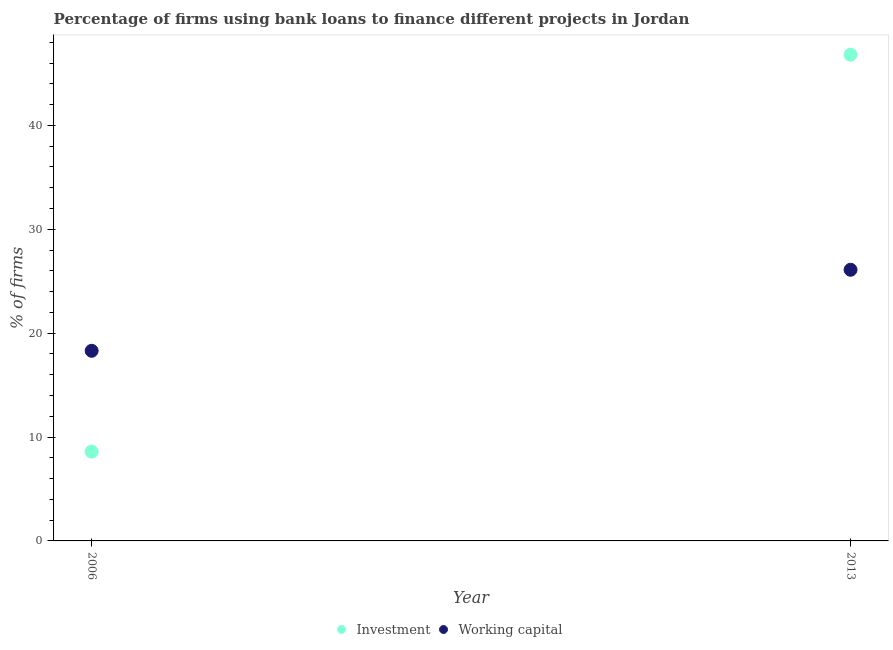Is the number of dotlines equal to the number of legend labels?
Give a very brief answer. Yes. Across all years, what is the maximum percentage of firms using banks to finance working capital?
Your answer should be very brief. 26.1. What is the total percentage of firms using banks to finance investment in the graph?
Make the answer very short. 55.4. What is the difference between the percentage of firms using banks to finance working capital in 2006 and that in 2013?
Your answer should be very brief. -7.8. What is the difference between the percentage of firms using banks to finance working capital in 2006 and the percentage of firms using banks to finance investment in 2013?
Provide a short and direct response. -28.5. What is the average percentage of firms using banks to finance working capital per year?
Provide a succinct answer. 22.2. In the year 2013, what is the difference between the percentage of firms using banks to finance working capital and percentage of firms using banks to finance investment?
Keep it short and to the point. -20.7. What is the ratio of the percentage of firms using banks to finance working capital in 2006 to that in 2013?
Give a very brief answer. 0.7. Is the percentage of firms using banks to finance investment in 2006 less than that in 2013?
Offer a very short reply. Yes. In how many years, is the percentage of firms using banks to finance investment greater than the average percentage of firms using banks to finance investment taken over all years?
Keep it short and to the point. 1. Does the percentage of firms using banks to finance working capital monotonically increase over the years?
Provide a short and direct response. Yes. How many years are there in the graph?
Give a very brief answer. 2. Does the graph contain any zero values?
Make the answer very short. No. Does the graph contain grids?
Keep it short and to the point. No. Where does the legend appear in the graph?
Ensure brevity in your answer.  Bottom center. How many legend labels are there?
Make the answer very short. 2. What is the title of the graph?
Your answer should be compact. Percentage of firms using bank loans to finance different projects in Jordan. Does "Passenger Transport Items" appear as one of the legend labels in the graph?
Offer a very short reply. No. What is the label or title of the X-axis?
Ensure brevity in your answer.  Year. What is the label or title of the Y-axis?
Your answer should be compact. % of firms. What is the % of firms in Investment in 2006?
Make the answer very short. 8.6. What is the % of firms of Working capital in 2006?
Your response must be concise. 18.3. What is the % of firms in Investment in 2013?
Keep it short and to the point. 46.8. What is the % of firms in Working capital in 2013?
Make the answer very short. 26.1. Across all years, what is the maximum % of firms in Investment?
Give a very brief answer. 46.8. Across all years, what is the maximum % of firms in Working capital?
Your answer should be very brief. 26.1. Across all years, what is the minimum % of firms of Investment?
Your response must be concise. 8.6. Across all years, what is the minimum % of firms of Working capital?
Ensure brevity in your answer.  18.3. What is the total % of firms in Investment in the graph?
Your response must be concise. 55.4. What is the total % of firms in Working capital in the graph?
Give a very brief answer. 44.4. What is the difference between the % of firms in Investment in 2006 and that in 2013?
Your answer should be compact. -38.2. What is the difference between the % of firms of Working capital in 2006 and that in 2013?
Your response must be concise. -7.8. What is the difference between the % of firms of Investment in 2006 and the % of firms of Working capital in 2013?
Offer a terse response. -17.5. What is the average % of firms of Investment per year?
Give a very brief answer. 27.7. In the year 2013, what is the difference between the % of firms of Investment and % of firms of Working capital?
Keep it short and to the point. 20.7. What is the ratio of the % of firms in Investment in 2006 to that in 2013?
Provide a short and direct response. 0.18. What is the ratio of the % of firms in Working capital in 2006 to that in 2013?
Make the answer very short. 0.7. What is the difference between the highest and the second highest % of firms in Investment?
Provide a succinct answer. 38.2. What is the difference between the highest and the lowest % of firms of Investment?
Your response must be concise. 38.2. What is the difference between the highest and the lowest % of firms in Working capital?
Provide a succinct answer. 7.8. 